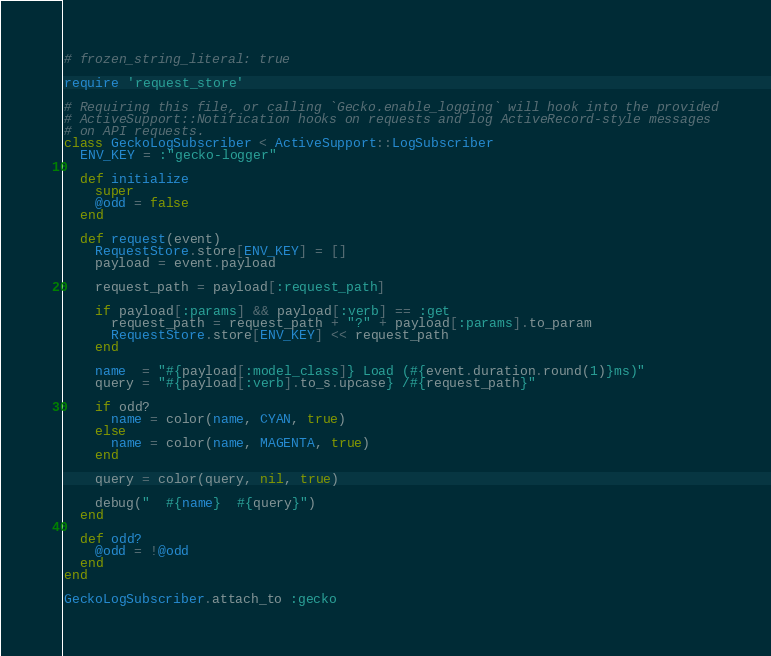<code> <loc_0><loc_0><loc_500><loc_500><_Ruby_># frozen_string_literal: true

require 'request_store'

# Requiring this file, or calling `Gecko.enable_logging` will hook into the provided
# ActiveSupport::Notification hooks on requests and log ActiveRecord-style messages
# on API requests.
class GeckoLogSubscriber < ActiveSupport::LogSubscriber
  ENV_KEY = :"gecko-logger"

  def initialize
    super
    @odd = false
  end

  def request(event)
    RequestStore.store[ENV_KEY] = []
    payload = event.payload

    request_path = payload[:request_path]

    if payload[:params] && payload[:verb] == :get
      request_path = request_path + "?" + payload[:params].to_param
      RequestStore.store[ENV_KEY] << request_path
    end

    name  = "#{payload[:model_class]} Load (#{event.duration.round(1)}ms)"
    query = "#{payload[:verb].to_s.upcase} /#{request_path}"

    if odd?
      name = color(name, CYAN, true)
    else
      name = color(name, MAGENTA, true)
    end

    query = color(query, nil, true)

    debug("  #{name}  #{query}")
  end

  def odd?
    @odd = !@odd
  end
end

GeckoLogSubscriber.attach_to :gecko
</code> 